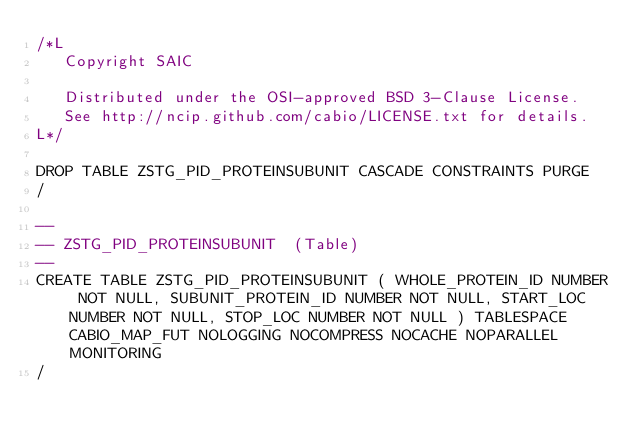<code> <loc_0><loc_0><loc_500><loc_500><_SQL_>/*L
   Copyright SAIC

   Distributed under the OSI-approved BSD 3-Clause License.
   See http://ncip.github.com/cabio/LICENSE.txt for details.
L*/

DROP TABLE ZSTG_PID_PROTEINSUBUNIT CASCADE CONSTRAINTS PURGE
/

--
-- ZSTG_PID_PROTEINSUBUNIT  (Table) 
--
CREATE TABLE ZSTG_PID_PROTEINSUBUNIT ( WHOLE_PROTEIN_ID NUMBER NOT NULL, SUBUNIT_PROTEIN_ID NUMBER NOT NULL, START_LOC NUMBER NOT NULL, STOP_LOC NUMBER NOT NULL ) TABLESPACE CABIO_MAP_FUT NOLOGGING NOCOMPRESS NOCACHE NOPARALLEL MONITORING
/


</code> 